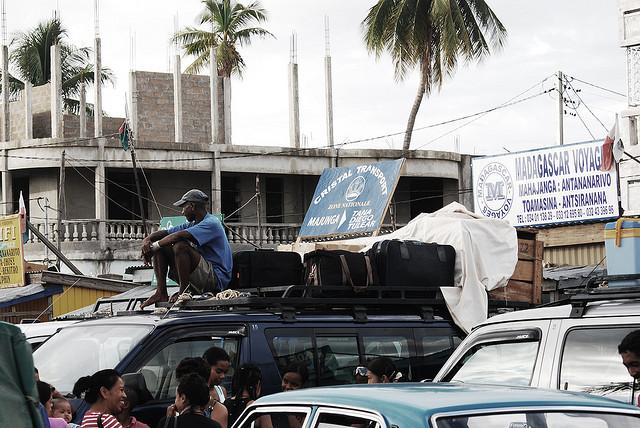These people are on what continent? Please explain your reasoning. africa. The people are african. 